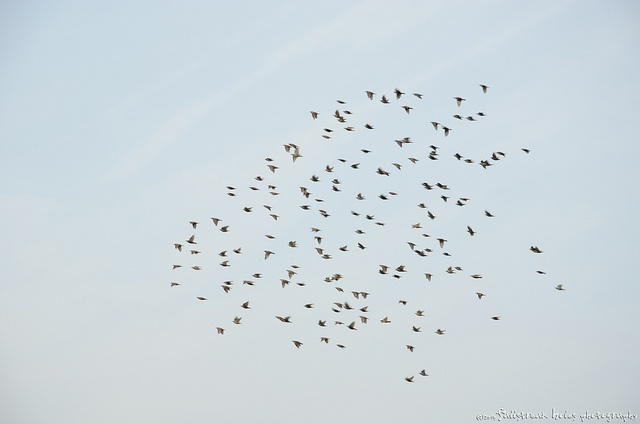Describe the objects in this image and their specific colors. I can see bird in lightblue, lightgray, darkgray, gray, and black tones, bird in lightblue, darkgray, gray, lightgray, and black tones, bird in lightblue, gray, and darkgray tones, bird in lightblue, darkgray, black, gray, and lightgray tones, and bird in lightblue, gray, darkgray, lightgray, and darkgreen tones in this image. 